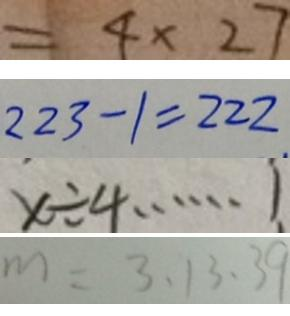Convert formula to latex. <formula><loc_0><loc_0><loc_500><loc_500>= 4 \times 2 7 
 2 2 3 - 1 = 2 2 2 . 
 x \div 4 \cdots 1 
 m = 3 , 1 3 , 3 9</formula> 